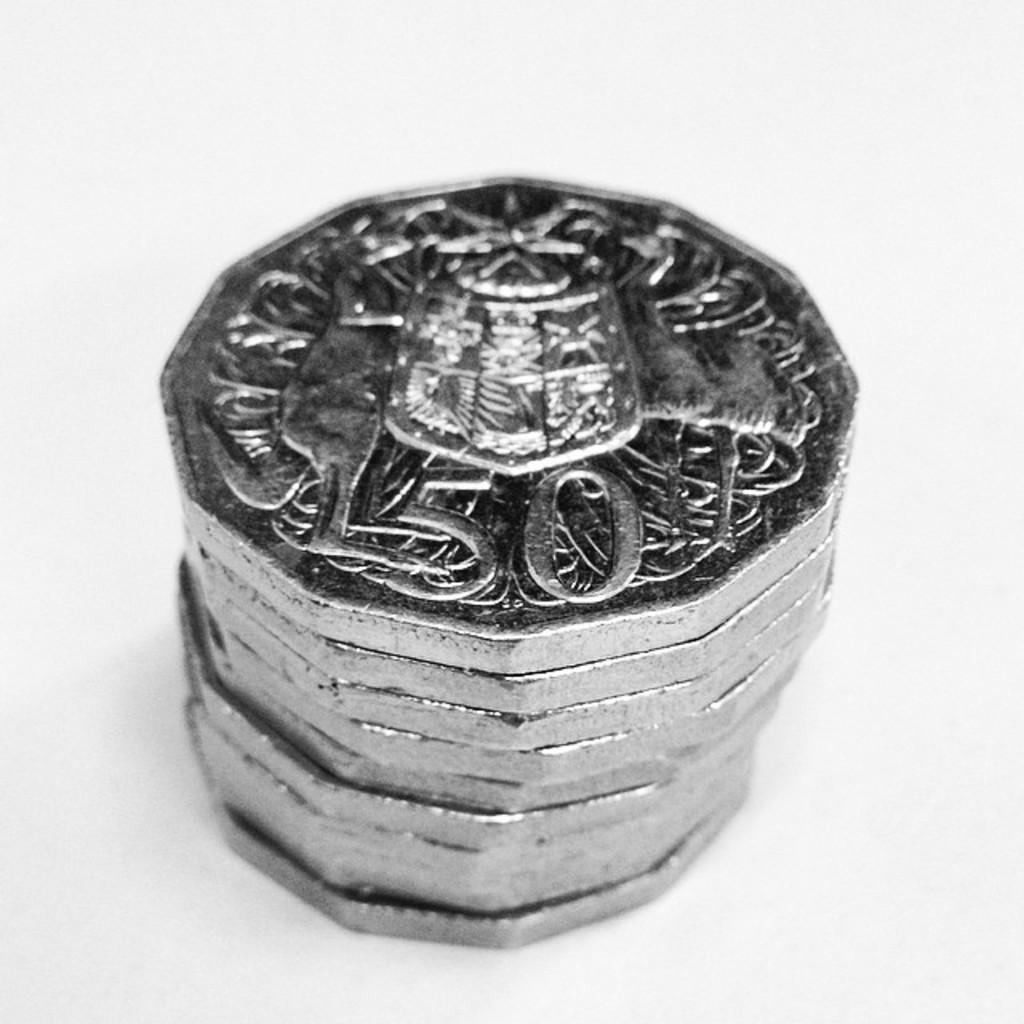What is the numerical value on the coin?
Your response must be concise. 50. 